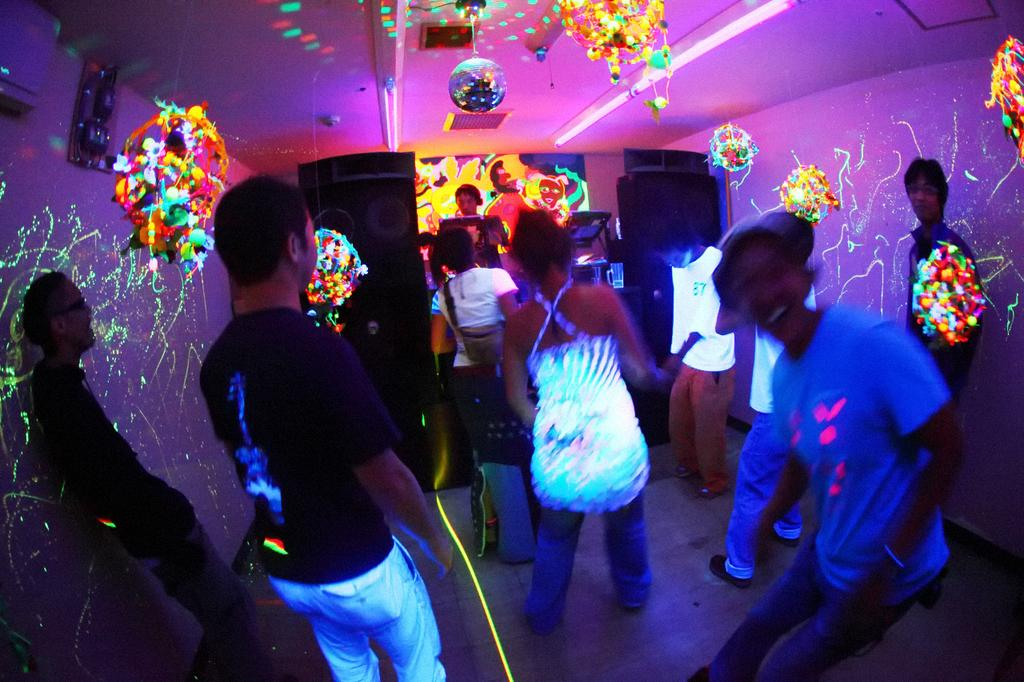Who or what is present in the image? There are people in the image. What can be seen around the people in the image? There are colorful lights around the image. What objects are visible in the image that might be related to sound? There are speakers in the image. What type of copper stem can be seen in the image? There is no copper stem present in the image. What record is being played on the speakers in the image? There is no record or indication of music being played in the image. 